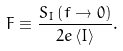<formula> <loc_0><loc_0><loc_500><loc_500>F \equiv \frac { S _ { I } \left ( f \rightarrow 0 \right ) } { 2 e \left \langle I \right \rangle } .</formula> 